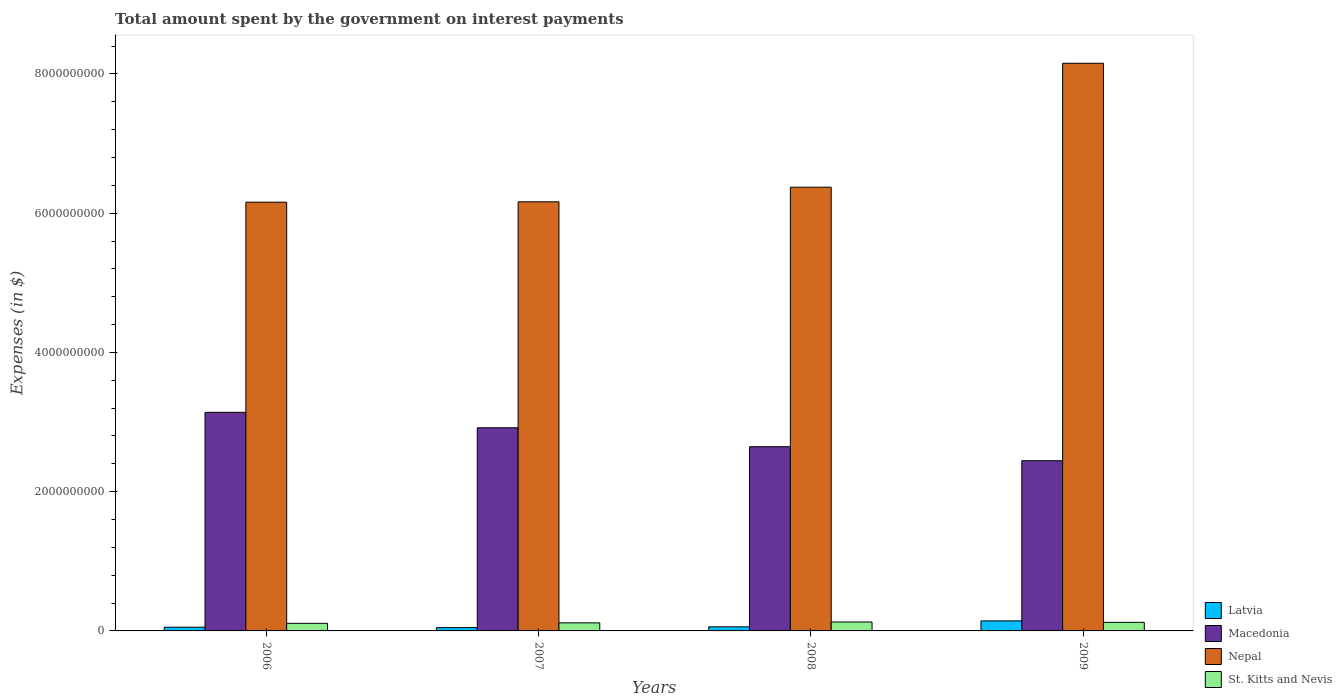How many different coloured bars are there?
Give a very brief answer. 4. How many bars are there on the 4th tick from the left?
Provide a short and direct response. 4. What is the label of the 3rd group of bars from the left?
Your answer should be compact. 2008. What is the amount spent on interest payments by the government in St. Kitts and Nevis in 2009?
Keep it short and to the point. 1.23e+08. Across all years, what is the maximum amount spent on interest payments by the government in Macedonia?
Make the answer very short. 3.14e+09. Across all years, what is the minimum amount spent on interest payments by the government in Macedonia?
Provide a short and direct response. 2.44e+09. In which year was the amount spent on interest payments by the government in Macedonia maximum?
Offer a very short reply. 2006. What is the total amount spent on interest payments by the government in St. Kitts and Nevis in the graph?
Your answer should be very brief. 4.77e+08. What is the difference between the amount spent on interest payments by the government in Latvia in 2006 and that in 2009?
Your answer should be very brief. -9.04e+07. What is the difference between the amount spent on interest payments by the government in St. Kitts and Nevis in 2009 and the amount spent on interest payments by the government in Latvia in 2006?
Your answer should be very brief. 6.96e+07. What is the average amount spent on interest payments by the government in Latvia per year?
Offer a very short reply. 7.61e+07. In the year 2009, what is the difference between the amount spent on interest payments by the government in Latvia and amount spent on interest payments by the government in Macedonia?
Your response must be concise. -2.30e+09. In how many years, is the amount spent on interest payments by the government in Nepal greater than 5200000000 $?
Provide a succinct answer. 4. What is the ratio of the amount spent on interest payments by the government in Latvia in 2008 to that in 2009?
Provide a short and direct response. 0.41. Is the difference between the amount spent on interest payments by the government in Latvia in 2008 and 2009 greater than the difference between the amount spent on interest payments by the government in Macedonia in 2008 and 2009?
Your answer should be compact. No. What is the difference between the highest and the second highest amount spent on interest payments by the government in Latvia?
Offer a very short reply. 8.50e+07. What is the difference between the highest and the lowest amount spent on interest payments by the government in St. Kitts and Nevis?
Keep it short and to the point. 1.91e+07. In how many years, is the amount spent on interest payments by the government in Nepal greater than the average amount spent on interest payments by the government in Nepal taken over all years?
Offer a very short reply. 1. Is the sum of the amount spent on interest payments by the government in St. Kitts and Nevis in 2006 and 2009 greater than the maximum amount spent on interest payments by the government in Latvia across all years?
Give a very brief answer. Yes. Is it the case that in every year, the sum of the amount spent on interest payments by the government in Latvia and amount spent on interest payments by the government in St. Kitts and Nevis is greater than the sum of amount spent on interest payments by the government in Macedonia and amount spent on interest payments by the government in Nepal?
Your answer should be very brief. No. What does the 3rd bar from the left in 2006 represents?
Your response must be concise. Nepal. What does the 3rd bar from the right in 2008 represents?
Provide a short and direct response. Macedonia. Is it the case that in every year, the sum of the amount spent on interest payments by the government in Latvia and amount spent on interest payments by the government in Macedonia is greater than the amount spent on interest payments by the government in St. Kitts and Nevis?
Provide a short and direct response. Yes. How many bars are there?
Give a very brief answer. 16. How many years are there in the graph?
Give a very brief answer. 4. What is the difference between two consecutive major ticks on the Y-axis?
Offer a very short reply. 2.00e+09. Are the values on the major ticks of Y-axis written in scientific E-notation?
Your answer should be very brief. No. Does the graph contain any zero values?
Make the answer very short. No. Does the graph contain grids?
Your response must be concise. No. Where does the legend appear in the graph?
Make the answer very short. Bottom right. What is the title of the graph?
Your answer should be very brief. Total amount spent by the government on interest payments. Does "Marshall Islands" appear as one of the legend labels in the graph?
Ensure brevity in your answer.  No. What is the label or title of the X-axis?
Provide a succinct answer. Years. What is the label or title of the Y-axis?
Ensure brevity in your answer.  Expenses (in $). What is the Expenses (in $) in Latvia in 2006?
Your response must be concise. 5.36e+07. What is the Expenses (in $) of Macedonia in 2006?
Offer a terse response. 3.14e+09. What is the Expenses (in $) of Nepal in 2006?
Make the answer very short. 6.16e+09. What is the Expenses (in $) of St. Kitts and Nevis in 2006?
Ensure brevity in your answer.  1.09e+08. What is the Expenses (in $) in Latvia in 2007?
Your response must be concise. 4.76e+07. What is the Expenses (in $) in Macedonia in 2007?
Keep it short and to the point. 2.92e+09. What is the Expenses (in $) of Nepal in 2007?
Keep it short and to the point. 6.16e+09. What is the Expenses (in $) of St. Kitts and Nevis in 2007?
Make the answer very short. 1.16e+08. What is the Expenses (in $) in Latvia in 2008?
Your answer should be very brief. 5.90e+07. What is the Expenses (in $) in Macedonia in 2008?
Provide a short and direct response. 2.65e+09. What is the Expenses (in $) of Nepal in 2008?
Offer a terse response. 6.37e+09. What is the Expenses (in $) of St. Kitts and Nevis in 2008?
Ensure brevity in your answer.  1.28e+08. What is the Expenses (in $) in Latvia in 2009?
Offer a very short reply. 1.44e+08. What is the Expenses (in $) of Macedonia in 2009?
Keep it short and to the point. 2.44e+09. What is the Expenses (in $) in Nepal in 2009?
Provide a succinct answer. 8.15e+09. What is the Expenses (in $) of St. Kitts and Nevis in 2009?
Offer a very short reply. 1.23e+08. Across all years, what is the maximum Expenses (in $) in Latvia?
Make the answer very short. 1.44e+08. Across all years, what is the maximum Expenses (in $) of Macedonia?
Make the answer very short. 3.14e+09. Across all years, what is the maximum Expenses (in $) in Nepal?
Your answer should be compact. 8.15e+09. Across all years, what is the maximum Expenses (in $) in St. Kitts and Nevis?
Provide a succinct answer. 1.28e+08. Across all years, what is the minimum Expenses (in $) in Latvia?
Ensure brevity in your answer.  4.76e+07. Across all years, what is the minimum Expenses (in $) of Macedonia?
Give a very brief answer. 2.44e+09. Across all years, what is the minimum Expenses (in $) of Nepal?
Your answer should be very brief. 6.16e+09. Across all years, what is the minimum Expenses (in $) of St. Kitts and Nevis?
Provide a short and direct response. 1.09e+08. What is the total Expenses (in $) of Latvia in the graph?
Offer a very short reply. 3.04e+08. What is the total Expenses (in $) in Macedonia in the graph?
Give a very brief answer. 1.11e+1. What is the total Expenses (in $) of Nepal in the graph?
Provide a short and direct response. 2.69e+1. What is the total Expenses (in $) of St. Kitts and Nevis in the graph?
Make the answer very short. 4.77e+08. What is the difference between the Expenses (in $) of Latvia in 2006 and that in 2007?
Your answer should be compact. 5.99e+06. What is the difference between the Expenses (in $) in Macedonia in 2006 and that in 2007?
Offer a terse response. 2.22e+08. What is the difference between the Expenses (in $) of Nepal in 2006 and that in 2007?
Your response must be concise. -5.30e+06. What is the difference between the Expenses (in $) in St. Kitts and Nevis in 2006 and that in 2007?
Ensure brevity in your answer.  -6.70e+06. What is the difference between the Expenses (in $) of Latvia in 2006 and that in 2008?
Make the answer very short. -5.40e+06. What is the difference between the Expenses (in $) of Macedonia in 2006 and that in 2008?
Your answer should be compact. 4.94e+08. What is the difference between the Expenses (in $) in Nepal in 2006 and that in 2008?
Keep it short and to the point. -2.15e+08. What is the difference between the Expenses (in $) of St. Kitts and Nevis in 2006 and that in 2008?
Provide a short and direct response. -1.91e+07. What is the difference between the Expenses (in $) of Latvia in 2006 and that in 2009?
Your response must be concise. -9.04e+07. What is the difference between the Expenses (in $) in Macedonia in 2006 and that in 2009?
Provide a succinct answer. 6.95e+08. What is the difference between the Expenses (in $) in Nepal in 2006 and that in 2009?
Offer a terse response. -2.00e+09. What is the difference between the Expenses (in $) in St. Kitts and Nevis in 2006 and that in 2009?
Ensure brevity in your answer.  -1.40e+07. What is the difference between the Expenses (in $) in Latvia in 2007 and that in 2008?
Give a very brief answer. -1.14e+07. What is the difference between the Expenses (in $) in Macedonia in 2007 and that in 2008?
Give a very brief answer. 2.72e+08. What is the difference between the Expenses (in $) of Nepal in 2007 and that in 2008?
Your answer should be very brief. -2.10e+08. What is the difference between the Expenses (in $) in St. Kitts and Nevis in 2007 and that in 2008?
Your response must be concise. -1.24e+07. What is the difference between the Expenses (in $) in Latvia in 2007 and that in 2009?
Provide a succinct answer. -9.64e+07. What is the difference between the Expenses (in $) in Macedonia in 2007 and that in 2009?
Ensure brevity in your answer.  4.73e+08. What is the difference between the Expenses (in $) of Nepal in 2007 and that in 2009?
Offer a terse response. -1.99e+09. What is the difference between the Expenses (in $) in St. Kitts and Nevis in 2007 and that in 2009?
Keep it short and to the point. -7.30e+06. What is the difference between the Expenses (in $) of Latvia in 2008 and that in 2009?
Provide a succinct answer. -8.50e+07. What is the difference between the Expenses (in $) in Macedonia in 2008 and that in 2009?
Your answer should be compact. 2.01e+08. What is the difference between the Expenses (in $) in Nepal in 2008 and that in 2009?
Give a very brief answer. -1.78e+09. What is the difference between the Expenses (in $) of St. Kitts and Nevis in 2008 and that in 2009?
Keep it short and to the point. 5.10e+06. What is the difference between the Expenses (in $) of Latvia in 2006 and the Expenses (in $) of Macedonia in 2007?
Keep it short and to the point. -2.86e+09. What is the difference between the Expenses (in $) of Latvia in 2006 and the Expenses (in $) of Nepal in 2007?
Provide a succinct answer. -6.11e+09. What is the difference between the Expenses (in $) of Latvia in 2006 and the Expenses (in $) of St. Kitts and Nevis in 2007?
Offer a very short reply. -6.23e+07. What is the difference between the Expenses (in $) in Macedonia in 2006 and the Expenses (in $) in Nepal in 2007?
Your answer should be very brief. -3.02e+09. What is the difference between the Expenses (in $) in Macedonia in 2006 and the Expenses (in $) in St. Kitts and Nevis in 2007?
Keep it short and to the point. 3.02e+09. What is the difference between the Expenses (in $) of Nepal in 2006 and the Expenses (in $) of St. Kitts and Nevis in 2007?
Provide a short and direct response. 6.04e+09. What is the difference between the Expenses (in $) of Latvia in 2006 and the Expenses (in $) of Macedonia in 2008?
Provide a short and direct response. -2.59e+09. What is the difference between the Expenses (in $) of Latvia in 2006 and the Expenses (in $) of Nepal in 2008?
Make the answer very short. -6.32e+09. What is the difference between the Expenses (in $) in Latvia in 2006 and the Expenses (in $) in St. Kitts and Nevis in 2008?
Your answer should be very brief. -7.47e+07. What is the difference between the Expenses (in $) in Macedonia in 2006 and the Expenses (in $) in Nepal in 2008?
Provide a short and direct response. -3.23e+09. What is the difference between the Expenses (in $) of Macedonia in 2006 and the Expenses (in $) of St. Kitts and Nevis in 2008?
Provide a succinct answer. 3.01e+09. What is the difference between the Expenses (in $) in Nepal in 2006 and the Expenses (in $) in St. Kitts and Nevis in 2008?
Offer a very short reply. 6.03e+09. What is the difference between the Expenses (in $) in Latvia in 2006 and the Expenses (in $) in Macedonia in 2009?
Make the answer very short. -2.39e+09. What is the difference between the Expenses (in $) in Latvia in 2006 and the Expenses (in $) in Nepal in 2009?
Keep it short and to the point. -8.10e+09. What is the difference between the Expenses (in $) of Latvia in 2006 and the Expenses (in $) of St. Kitts and Nevis in 2009?
Offer a terse response. -6.96e+07. What is the difference between the Expenses (in $) in Macedonia in 2006 and the Expenses (in $) in Nepal in 2009?
Ensure brevity in your answer.  -5.01e+09. What is the difference between the Expenses (in $) of Macedonia in 2006 and the Expenses (in $) of St. Kitts and Nevis in 2009?
Keep it short and to the point. 3.02e+09. What is the difference between the Expenses (in $) of Nepal in 2006 and the Expenses (in $) of St. Kitts and Nevis in 2009?
Offer a terse response. 6.04e+09. What is the difference between the Expenses (in $) in Latvia in 2007 and the Expenses (in $) in Macedonia in 2008?
Your response must be concise. -2.60e+09. What is the difference between the Expenses (in $) in Latvia in 2007 and the Expenses (in $) in Nepal in 2008?
Provide a succinct answer. -6.33e+09. What is the difference between the Expenses (in $) of Latvia in 2007 and the Expenses (in $) of St. Kitts and Nevis in 2008?
Keep it short and to the point. -8.07e+07. What is the difference between the Expenses (in $) of Macedonia in 2007 and the Expenses (in $) of Nepal in 2008?
Make the answer very short. -3.46e+09. What is the difference between the Expenses (in $) of Macedonia in 2007 and the Expenses (in $) of St. Kitts and Nevis in 2008?
Your answer should be compact. 2.79e+09. What is the difference between the Expenses (in $) in Nepal in 2007 and the Expenses (in $) in St. Kitts and Nevis in 2008?
Your answer should be very brief. 6.04e+09. What is the difference between the Expenses (in $) of Latvia in 2007 and the Expenses (in $) of Macedonia in 2009?
Provide a succinct answer. -2.40e+09. What is the difference between the Expenses (in $) of Latvia in 2007 and the Expenses (in $) of Nepal in 2009?
Offer a very short reply. -8.11e+09. What is the difference between the Expenses (in $) of Latvia in 2007 and the Expenses (in $) of St. Kitts and Nevis in 2009?
Your answer should be very brief. -7.56e+07. What is the difference between the Expenses (in $) of Macedonia in 2007 and the Expenses (in $) of Nepal in 2009?
Provide a short and direct response. -5.24e+09. What is the difference between the Expenses (in $) of Macedonia in 2007 and the Expenses (in $) of St. Kitts and Nevis in 2009?
Your response must be concise. 2.80e+09. What is the difference between the Expenses (in $) in Nepal in 2007 and the Expenses (in $) in St. Kitts and Nevis in 2009?
Give a very brief answer. 6.04e+09. What is the difference between the Expenses (in $) in Latvia in 2008 and the Expenses (in $) in Macedonia in 2009?
Give a very brief answer. -2.39e+09. What is the difference between the Expenses (in $) of Latvia in 2008 and the Expenses (in $) of Nepal in 2009?
Offer a terse response. -8.10e+09. What is the difference between the Expenses (in $) of Latvia in 2008 and the Expenses (in $) of St. Kitts and Nevis in 2009?
Keep it short and to the point. -6.42e+07. What is the difference between the Expenses (in $) of Macedonia in 2008 and the Expenses (in $) of Nepal in 2009?
Your response must be concise. -5.51e+09. What is the difference between the Expenses (in $) in Macedonia in 2008 and the Expenses (in $) in St. Kitts and Nevis in 2009?
Make the answer very short. 2.52e+09. What is the difference between the Expenses (in $) in Nepal in 2008 and the Expenses (in $) in St. Kitts and Nevis in 2009?
Offer a very short reply. 6.25e+09. What is the average Expenses (in $) in Latvia per year?
Your response must be concise. 7.61e+07. What is the average Expenses (in $) in Macedonia per year?
Keep it short and to the point. 2.79e+09. What is the average Expenses (in $) in Nepal per year?
Ensure brevity in your answer.  6.71e+09. What is the average Expenses (in $) of St. Kitts and Nevis per year?
Ensure brevity in your answer.  1.19e+08. In the year 2006, what is the difference between the Expenses (in $) of Latvia and Expenses (in $) of Macedonia?
Your response must be concise. -3.09e+09. In the year 2006, what is the difference between the Expenses (in $) in Latvia and Expenses (in $) in Nepal?
Provide a succinct answer. -6.11e+09. In the year 2006, what is the difference between the Expenses (in $) of Latvia and Expenses (in $) of St. Kitts and Nevis?
Provide a succinct answer. -5.56e+07. In the year 2006, what is the difference between the Expenses (in $) of Macedonia and Expenses (in $) of Nepal?
Your answer should be compact. -3.02e+09. In the year 2006, what is the difference between the Expenses (in $) of Macedonia and Expenses (in $) of St. Kitts and Nevis?
Offer a very short reply. 3.03e+09. In the year 2006, what is the difference between the Expenses (in $) in Nepal and Expenses (in $) in St. Kitts and Nevis?
Your response must be concise. 6.05e+09. In the year 2007, what is the difference between the Expenses (in $) of Latvia and Expenses (in $) of Macedonia?
Your answer should be compact. -2.87e+09. In the year 2007, what is the difference between the Expenses (in $) of Latvia and Expenses (in $) of Nepal?
Provide a succinct answer. -6.12e+09. In the year 2007, what is the difference between the Expenses (in $) of Latvia and Expenses (in $) of St. Kitts and Nevis?
Offer a very short reply. -6.83e+07. In the year 2007, what is the difference between the Expenses (in $) of Macedonia and Expenses (in $) of Nepal?
Your response must be concise. -3.25e+09. In the year 2007, what is the difference between the Expenses (in $) of Macedonia and Expenses (in $) of St. Kitts and Nevis?
Make the answer very short. 2.80e+09. In the year 2007, what is the difference between the Expenses (in $) in Nepal and Expenses (in $) in St. Kitts and Nevis?
Your answer should be compact. 6.05e+09. In the year 2008, what is the difference between the Expenses (in $) of Latvia and Expenses (in $) of Macedonia?
Provide a short and direct response. -2.59e+09. In the year 2008, what is the difference between the Expenses (in $) in Latvia and Expenses (in $) in Nepal?
Give a very brief answer. -6.31e+09. In the year 2008, what is the difference between the Expenses (in $) of Latvia and Expenses (in $) of St. Kitts and Nevis?
Your response must be concise. -6.93e+07. In the year 2008, what is the difference between the Expenses (in $) in Macedonia and Expenses (in $) in Nepal?
Provide a short and direct response. -3.73e+09. In the year 2008, what is the difference between the Expenses (in $) of Macedonia and Expenses (in $) of St. Kitts and Nevis?
Keep it short and to the point. 2.52e+09. In the year 2008, what is the difference between the Expenses (in $) of Nepal and Expenses (in $) of St. Kitts and Nevis?
Offer a terse response. 6.25e+09. In the year 2009, what is the difference between the Expenses (in $) of Latvia and Expenses (in $) of Macedonia?
Ensure brevity in your answer.  -2.30e+09. In the year 2009, what is the difference between the Expenses (in $) of Latvia and Expenses (in $) of Nepal?
Offer a terse response. -8.01e+09. In the year 2009, what is the difference between the Expenses (in $) of Latvia and Expenses (in $) of St. Kitts and Nevis?
Your response must be concise. 2.08e+07. In the year 2009, what is the difference between the Expenses (in $) of Macedonia and Expenses (in $) of Nepal?
Keep it short and to the point. -5.71e+09. In the year 2009, what is the difference between the Expenses (in $) of Macedonia and Expenses (in $) of St. Kitts and Nevis?
Give a very brief answer. 2.32e+09. In the year 2009, what is the difference between the Expenses (in $) of Nepal and Expenses (in $) of St. Kitts and Nevis?
Provide a succinct answer. 8.03e+09. What is the ratio of the Expenses (in $) of Latvia in 2006 to that in 2007?
Make the answer very short. 1.13. What is the ratio of the Expenses (in $) of Macedonia in 2006 to that in 2007?
Provide a succinct answer. 1.08. What is the ratio of the Expenses (in $) of Nepal in 2006 to that in 2007?
Provide a short and direct response. 1. What is the ratio of the Expenses (in $) in St. Kitts and Nevis in 2006 to that in 2007?
Your response must be concise. 0.94. What is the ratio of the Expenses (in $) of Latvia in 2006 to that in 2008?
Keep it short and to the point. 0.91. What is the ratio of the Expenses (in $) of Macedonia in 2006 to that in 2008?
Your answer should be compact. 1.19. What is the ratio of the Expenses (in $) of Nepal in 2006 to that in 2008?
Offer a terse response. 0.97. What is the ratio of the Expenses (in $) in St. Kitts and Nevis in 2006 to that in 2008?
Ensure brevity in your answer.  0.85. What is the ratio of the Expenses (in $) of Latvia in 2006 to that in 2009?
Your response must be concise. 0.37. What is the ratio of the Expenses (in $) of Macedonia in 2006 to that in 2009?
Ensure brevity in your answer.  1.28. What is the ratio of the Expenses (in $) in Nepal in 2006 to that in 2009?
Ensure brevity in your answer.  0.76. What is the ratio of the Expenses (in $) in St. Kitts and Nevis in 2006 to that in 2009?
Offer a terse response. 0.89. What is the ratio of the Expenses (in $) in Latvia in 2007 to that in 2008?
Give a very brief answer. 0.81. What is the ratio of the Expenses (in $) in Macedonia in 2007 to that in 2008?
Your answer should be very brief. 1.1. What is the ratio of the Expenses (in $) in Nepal in 2007 to that in 2008?
Your response must be concise. 0.97. What is the ratio of the Expenses (in $) of St. Kitts and Nevis in 2007 to that in 2008?
Offer a terse response. 0.9. What is the ratio of the Expenses (in $) of Latvia in 2007 to that in 2009?
Your response must be concise. 0.33. What is the ratio of the Expenses (in $) in Macedonia in 2007 to that in 2009?
Provide a succinct answer. 1.19. What is the ratio of the Expenses (in $) of Nepal in 2007 to that in 2009?
Your answer should be compact. 0.76. What is the ratio of the Expenses (in $) in St. Kitts and Nevis in 2007 to that in 2009?
Give a very brief answer. 0.94. What is the ratio of the Expenses (in $) of Latvia in 2008 to that in 2009?
Offer a terse response. 0.41. What is the ratio of the Expenses (in $) in Macedonia in 2008 to that in 2009?
Offer a terse response. 1.08. What is the ratio of the Expenses (in $) in Nepal in 2008 to that in 2009?
Offer a very short reply. 0.78. What is the ratio of the Expenses (in $) in St. Kitts and Nevis in 2008 to that in 2009?
Ensure brevity in your answer.  1.04. What is the difference between the highest and the second highest Expenses (in $) of Latvia?
Make the answer very short. 8.50e+07. What is the difference between the highest and the second highest Expenses (in $) in Macedonia?
Keep it short and to the point. 2.22e+08. What is the difference between the highest and the second highest Expenses (in $) in Nepal?
Your answer should be very brief. 1.78e+09. What is the difference between the highest and the second highest Expenses (in $) in St. Kitts and Nevis?
Give a very brief answer. 5.10e+06. What is the difference between the highest and the lowest Expenses (in $) of Latvia?
Give a very brief answer. 9.64e+07. What is the difference between the highest and the lowest Expenses (in $) of Macedonia?
Your response must be concise. 6.95e+08. What is the difference between the highest and the lowest Expenses (in $) of Nepal?
Offer a terse response. 2.00e+09. What is the difference between the highest and the lowest Expenses (in $) in St. Kitts and Nevis?
Your answer should be compact. 1.91e+07. 